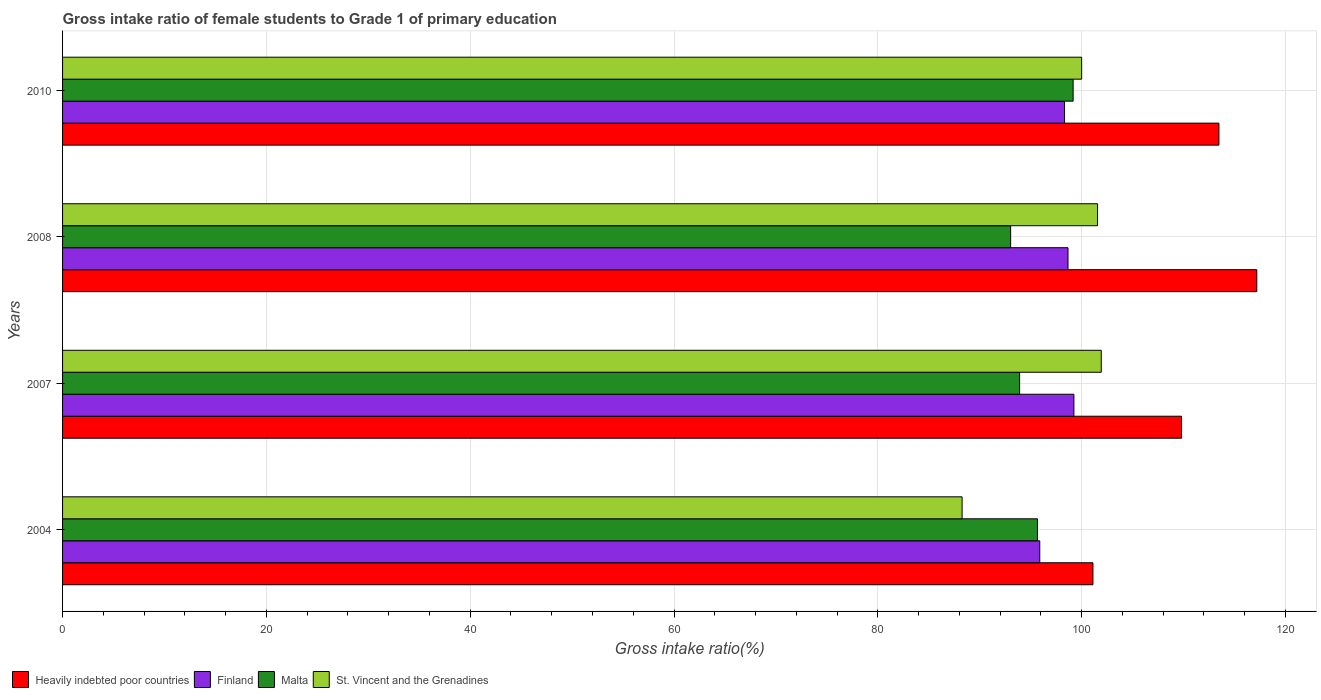How many groups of bars are there?
Make the answer very short. 4. How many bars are there on the 3rd tick from the top?
Offer a terse response. 4. How many bars are there on the 3rd tick from the bottom?
Provide a succinct answer. 4. What is the label of the 3rd group of bars from the top?
Give a very brief answer. 2007. In how many cases, is the number of bars for a given year not equal to the number of legend labels?
Provide a short and direct response. 0. What is the gross intake ratio in Malta in 2007?
Your response must be concise. 93.91. Across all years, what is the maximum gross intake ratio in Finland?
Give a very brief answer. 99.24. Across all years, what is the minimum gross intake ratio in Heavily indebted poor countries?
Your response must be concise. 101.11. What is the total gross intake ratio in St. Vincent and the Grenadines in the graph?
Your answer should be very brief. 391.75. What is the difference between the gross intake ratio in Finland in 2004 and that in 2007?
Give a very brief answer. -3.35. What is the difference between the gross intake ratio in Finland in 2010 and the gross intake ratio in Heavily indebted poor countries in 2008?
Provide a succinct answer. -18.86. What is the average gross intake ratio in St. Vincent and the Grenadines per year?
Your answer should be very brief. 97.94. In the year 2004, what is the difference between the gross intake ratio in St. Vincent and the Grenadines and gross intake ratio in Finland?
Offer a terse response. -7.62. In how many years, is the gross intake ratio in Finland greater than 32 %?
Give a very brief answer. 4. What is the ratio of the gross intake ratio in Malta in 2007 to that in 2010?
Your response must be concise. 0.95. Is the gross intake ratio in Finland in 2007 less than that in 2008?
Give a very brief answer. No. Is the difference between the gross intake ratio in St. Vincent and the Grenadines in 2008 and 2010 greater than the difference between the gross intake ratio in Finland in 2008 and 2010?
Your answer should be very brief. Yes. What is the difference between the highest and the second highest gross intake ratio in Heavily indebted poor countries?
Offer a terse response. 3.71. What is the difference between the highest and the lowest gross intake ratio in Finland?
Offer a terse response. 3.35. What does the 3rd bar from the bottom in 2007 represents?
Your response must be concise. Malta. How many years are there in the graph?
Ensure brevity in your answer.  4. Are the values on the major ticks of X-axis written in scientific E-notation?
Provide a succinct answer. No. Does the graph contain grids?
Give a very brief answer. Yes. Where does the legend appear in the graph?
Your answer should be compact. Bottom left. What is the title of the graph?
Your response must be concise. Gross intake ratio of female students to Grade 1 of primary education. What is the label or title of the X-axis?
Provide a short and direct response. Gross intake ratio(%). What is the Gross intake ratio(%) of Heavily indebted poor countries in 2004?
Your response must be concise. 101.11. What is the Gross intake ratio(%) of Finland in 2004?
Ensure brevity in your answer.  95.89. What is the Gross intake ratio(%) in Malta in 2004?
Ensure brevity in your answer.  95.67. What is the Gross intake ratio(%) in St. Vincent and the Grenadines in 2004?
Offer a very short reply. 88.27. What is the Gross intake ratio(%) in Heavily indebted poor countries in 2007?
Offer a very short reply. 109.8. What is the Gross intake ratio(%) of Finland in 2007?
Ensure brevity in your answer.  99.24. What is the Gross intake ratio(%) in Malta in 2007?
Your response must be concise. 93.91. What is the Gross intake ratio(%) in St. Vincent and the Grenadines in 2007?
Provide a succinct answer. 101.93. What is the Gross intake ratio(%) of Heavily indebted poor countries in 2008?
Make the answer very short. 117.18. What is the Gross intake ratio(%) of Finland in 2008?
Your answer should be compact. 98.66. What is the Gross intake ratio(%) in Malta in 2008?
Give a very brief answer. 93.03. What is the Gross intake ratio(%) in St. Vincent and the Grenadines in 2008?
Give a very brief answer. 101.56. What is the Gross intake ratio(%) of Heavily indebted poor countries in 2010?
Keep it short and to the point. 113.47. What is the Gross intake ratio(%) in Finland in 2010?
Offer a very short reply. 98.32. What is the Gross intake ratio(%) of Malta in 2010?
Make the answer very short. 99.16. What is the Gross intake ratio(%) of St. Vincent and the Grenadines in 2010?
Make the answer very short. 100. Across all years, what is the maximum Gross intake ratio(%) of Heavily indebted poor countries?
Ensure brevity in your answer.  117.18. Across all years, what is the maximum Gross intake ratio(%) of Finland?
Your answer should be very brief. 99.24. Across all years, what is the maximum Gross intake ratio(%) of Malta?
Your response must be concise. 99.16. Across all years, what is the maximum Gross intake ratio(%) of St. Vincent and the Grenadines?
Provide a short and direct response. 101.93. Across all years, what is the minimum Gross intake ratio(%) in Heavily indebted poor countries?
Your answer should be compact. 101.11. Across all years, what is the minimum Gross intake ratio(%) of Finland?
Offer a very short reply. 95.89. Across all years, what is the minimum Gross intake ratio(%) in Malta?
Give a very brief answer. 93.03. Across all years, what is the minimum Gross intake ratio(%) of St. Vincent and the Grenadines?
Offer a terse response. 88.27. What is the total Gross intake ratio(%) in Heavily indebted poor countries in the graph?
Your response must be concise. 441.56. What is the total Gross intake ratio(%) of Finland in the graph?
Keep it short and to the point. 392.11. What is the total Gross intake ratio(%) in Malta in the graph?
Provide a succinct answer. 381.77. What is the total Gross intake ratio(%) in St. Vincent and the Grenadines in the graph?
Provide a succinct answer. 391.75. What is the difference between the Gross intake ratio(%) in Heavily indebted poor countries in 2004 and that in 2007?
Provide a short and direct response. -8.69. What is the difference between the Gross intake ratio(%) in Finland in 2004 and that in 2007?
Your answer should be very brief. -3.35. What is the difference between the Gross intake ratio(%) in Malta in 2004 and that in 2007?
Offer a terse response. 1.75. What is the difference between the Gross intake ratio(%) of St. Vincent and the Grenadines in 2004 and that in 2007?
Offer a terse response. -13.66. What is the difference between the Gross intake ratio(%) in Heavily indebted poor countries in 2004 and that in 2008?
Make the answer very short. -16.08. What is the difference between the Gross intake ratio(%) in Finland in 2004 and that in 2008?
Give a very brief answer. -2.77. What is the difference between the Gross intake ratio(%) of Malta in 2004 and that in 2008?
Provide a succinct answer. 2.63. What is the difference between the Gross intake ratio(%) in St. Vincent and the Grenadines in 2004 and that in 2008?
Provide a short and direct response. -13.29. What is the difference between the Gross intake ratio(%) in Heavily indebted poor countries in 2004 and that in 2010?
Offer a very short reply. -12.36. What is the difference between the Gross intake ratio(%) of Finland in 2004 and that in 2010?
Make the answer very short. -2.43. What is the difference between the Gross intake ratio(%) of Malta in 2004 and that in 2010?
Give a very brief answer. -3.5. What is the difference between the Gross intake ratio(%) of St. Vincent and the Grenadines in 2004 and that in 2010?
Offer a very short reply. -11.73. What is the difference between the Gross intake ratio(%) in Heavily indebted poor countries in 2007 and that in 2008?
Provide a succinct answer. -7.38. What is the difference between the Gross intake ratio(%) in Finland in 2007 and that in 2008?
Make the answer very short. 0.58. What is the difference between the Gross intake ratio(%) in Malta in 2007 and that in 2008?
Make the answer very short. 0.88. What is the difference between the Gross intake ratio(%) in St. Vincent and the Grenadines in 2007 and that in 2008?
Provide a succinct answer. 0.36. What is the difference between the Gross intake ratio(%) of Heavily indebted poor countries in 2007 and that in 2010?
Provide a succinct answer. -3.67. What is the difference between the Gross intake ratio(%) of Finland in 2007 and that in 2010?
Offer a terse response. 0.92. What is the difference between the Gross intake ratio(%) of Malta in 2007 and that in 2010?
Provide a succinct answer. -5.25. What is the difference between the Gross intake ratio(%) of St. Vincent and the Grenadines in 2007 and that in 2010?
Ensure brevity in your answer.  1.93. What is the difference between the Gross intake ratio(%) in Heavily indebted poor countries in 2008 and that in 2010?
Keep it short and to the point. 3.71. What is the difference between the Gross intake ratio(%) of Finland in 2008 and that in 2010?
Your response must be concise. 0.34. What is the difference between the Gross intake ratio(%) in Malta in 2008 and that in 2010?
Offer a terse response. -6.13. What is the difference between the Gross intake ratio(%) in St. Vincent and the Grenadines in 2008 and that in 2010?
Give a very brief answer. 1.56. What is the difference between the Gross intake ratio(%) of Heavily indebted poor countries in 2004 and the Gross intake ratio(%) of Finland in 2007?
Provide a short and direct response. 1.87. What is the difference between the Gross intake ratio(%) of Heavily indebted poor countries in 2004 and the Gross intake ratio(%) of Malta in 2007?
Provide a short and direct response. 7.2. What is the difference between the Gross intake ratio(%) of Heavily indebted poor countries in 2004 and the Gross intake ratio(%) of St. Vincent and the Grenadines in 2007?
Make the answer very short. -0.82. What is the difference between the Gross intake ratio(%) of Finland in 2004 and the Gross intake ratio(%) of Malta in 2007?
Your response must be concise. 1.98. What is the difference between the Gross intake ratio(%) of Finland in 2004 and the Gross intake ratio(%) of St. Vincent and the Grenadines in 2007?
Provide a short and direct response. -6.03. What is the difference between the Gross intake ratio(%) of Malta in 2004 and the Gross intake ratio(%) of St. Vincent and the Grenadines in 2007?
Keep it short and to the point. -6.26. What is the difference between the Gross intake ratio(%) in Heavily indebted poor countries in 2004 and the Gross intake ratio(%) in Finland in 2008?
Offer a very short reply. 2.45. What is the difference between the Gross intake ratio(%) of Heavily indebted poor countries in 2004 and the Gross intake ratio(%) of Malta in 2008?
Your response must be concise. 8.07. What is the difference between the Gross intake ratio(%) of Heavily indebted poor countries in 2004 and the Gross intake ratio(%) of St. Vincent and the Grenadines in 2008?
Provide a short and direct response. -0.45. What is the difference between the Gross intake ratio(%) of Finland in 2004 and the Gross intake ratio(%) of Malta in 2008?
Ensure brevity in your answer.  2.86. What is the difference between the Gross intake ratio(%) of Finland in 2004 and the Gross intake ratio(%) of St. Vincent and the Grenadines in 2008?
Offer a very short reply. -5.67. What is the difference between the Gross intake ratio(%) of Malta in 2004 and the Gross intake ratio(%) of St. Vincent and the Grenadines in 2008?
Ensure brevity in your answer.  -5.9. What is the difference between the Gross intake ratio(%) in Heavily indebted poor countries in 2004 and the Gross intake ratio(%) in Finland in 2010?
Provide a succinct answer. 2.79. What is the difference between the Gross intake ratio(%) of Heavily indebted poor countries in 2004 and the Gross intake ratio(%) of Malta in 2010?
Offer a very short reply. 1.94. What is the difference between the Gross intake ratio(%) in Heavily indebted poor countries in 2004 and the Gross intake ratio(%) in St. Vincent and the Grenadines in 2010?
Keep it short and to the point. 1.11. What is the difference between the Gross intake ratio(%) in Finland in 2004 and the Gross intake ratio(%) in Malta in 2010?
Provide a short and direct response. -3.27. What is the difference between the Gross intake ratio(%) in Finland in 2004 and the Gross intake ratio(%) in St. Vincent and the Grenadines in 2010?
Your answer should be compact. -4.11. What is the difference between the Gross intake ratio(%) of Malta in 2004 and the Gross intake ratio(%) of St. Vincent and the Grenadines in 2010?
Your response must be concise. -4.33. What is the difference between the Gross intake ratio(%) of Heavily indebted poor countries in 2007 and the Gross intake ratio(%) of Finland in 2008?
Ensure brevity in your answer.  11.14. What is the difference between the Gross intake ratio(%) in Heavily indebted poor countries in 2007 and the Gross intake ratio(%) in Malta in 2008?
Your response must be concise. 16.77. What is the difference between the Gross intake ratio(%) of Heavily indebted poor countries in 2007 and the Gross intake ratio(%) of St. Vincent and the Grenadines in 2008?
Your answer should be compact. 8.24. What is the difference between the Gross intake ratio(%) of Finland in 2007 and the Gross intake ratio(%) of Malta in 2008?
Your answer should be compact. 6.21. What is the difference between the Gross intake ratio(%) of Finland in 2007 and the Gross intake ratio(%) of St. Vincent and the Grenadines in 2008?
Give a very brief answer. -2.32. What is the difference between the Gross intake ratio(%) of Malta in 2007 and the Gross intake ratio(%) of St. Vincent and the Grenadines in 2008?
Your response must be concise. -7.65. What is the difference between the Gross intake ratio(%) in Heavily indebted poor countries in 2007 and the Gross intake ratio(%) in Finland in 2010?
Make the answer very short. 11.48. What is the difference between the Gross intake ratio(%) in Heavily indebted poor countries in 2007 and the Gross intake ratio(%) in Malta in 2010?
Offer a terse response. 10.64. What is the difference between the Gross intake ratio(%) of Heavily indebted poor countries in 2007 and the Gross intake ratio(%) of St. Vincent and the Grenadines in 2010?
Your response must be concise. 9.8. What is the difference between the Gross intake ratio(%) in Finland in 2007 and the Gross intake ratio(%) in Malta in 2010?
Your answer should be compact. 0.08. What is the difference between the Gross intake ratio(%) in Finland in 2007 and the Gross intake ratio(%) in St. Vincent and the Grenadines in 2010?
Keep it short and to the point. -0.76. What is the difference between the Gross intake ratio(%) in Malta in 2007 and the Gross intake ratio(%) in St. Vincent and the Grenadines in 2010?
Offer a very short reply. -6.09. What is the difference between the Gross intake ratio(%) of Heavily indebted poor countries in 2008 and the Gross intake ratio(%) of Finland in 2010?
Provide a succinct answer. 18.86. What is the difference between the Gross intake ratio(%) in Heavily indebted poor countries in 2008 and the Gross intake ratio(%) in Malta in 2010?
Ensure brevity in your answer.  18.02. What is the difference between the Gross intake ratio(%) of Heavily indebted poor countries in 2008 and the Gross intake ratio(%) of St. Vincent and the Grenadines in 2010?
Provide a short and direct response. 17.18. What is the difference between the Gross intake ratio(%) of Finland in 2008 and the Gross intake ratio(%) of Malta in 2010?
Offer a terse response. -0.5. What is the difference between the Gross intake ratio(%) of Finland in 2008 and the Gross intake ratio(%) of St. Vincent and the Grenadines in 2010?
Your answer should be compact. -1.34. What is the difference between the Gross intake ratio(%) in Malta in 2008 and the Gross intake ratio(%) in St. Vincent and the Grenadines in 2010?
Make the answer very short. -6.97. What is the average Gross intake ratio(%) in Heavily indebted poor countries per year?
Offer a very short reply. 110.39. What is the average Gross intake ratio(%) in Finland per year?
Your answer should be very brief. 98.03. What is the average Gross intake ratio(%) in Malta per year?
Your response must be concise. 95.44. What is the average Gross intake ratio(%) of St. Vincent and the Grenadines per year?
Provide a succinct answer. 97.94. In the year 2004, what is the difference between the Gross intake ratio(%) in Heavily indebted poor countries and Gross intake ratio(%) in Finland?
Keep it short and to the point. 5.22. In the year 2004, what is the difference between the Gross intake ratio(%) in Heavily indebted poor countries and Gross intake ratio(%) in Malta?
Your response must be concise. 5.44. In the year 2004, what is the difference between the Gross intake ratio(%) of Heavily indebted poor countries and Gross intake ratio(%) of St. Vincent and the Grenadines?
Keep it short and to the point. 12.84. In the year 2004, what is the difference between the Gross intake ratio(%) in Finland and Gross intake ratio(%) in Malta?
Offer a very short reply. 0.23. In the year 2004, what is the difference between the Gross intake ratio(%) in Finland and Gross intake ratio(%) in St. Vincent and the Grenadines?
Your answer should be compact. 7.62. In the year 2004, what is the difference between the Gross intake ratio(%) in Malta and Gross intake ratio(%) in St. Vincent and the Grenadines?
Offer a very short reply. 7.4. In the year 2007, what is the difference between the Gross intake ratio(%) of Heavily indebted poor countries and Gross intake ratio(%) of Finland?
Keep it short and to the point. 10.56. In the year 2007, what is the difference between the Gross intake ratio(%) in Heavily indebted poor countries and Gross intake ratio(%) in Malta?
Offer a very short reply. 15.89. In the year 2007, what is the difference between the Gross intake ratio(%) in Heavily indebted poor countries and Gross intake ratio(%) in St. Vincent and the Grenadines?
Your answer should be compact. 7.88. In the year 2007, what is the difference between the Gross intake ratio(%) in Finland and Gross intake ratio(%) in Malta?
Make the answer very short. 5.33. In the year 2007, what is the difference between the Gross intake ratio(%) of Finland and Gross intake ratio(%) of St. Vincent and the Grenadines?
Provide a short and direct response. -2.68. In the year 2007, what is the difference between the Gross intake ratio(%) of Malta and Gross intake ratio(%) of St. Vincent and the Grenadines?
Make the answer very short. -8.01. In the year 2008, what is the difference between the Gross intake ratio(%) in Heavily indebted poor countries and Gross intake ratio(%) in Finland?
Provide a succinct answer. 18.52. In the year 2008, what is the difference between the Gross intake ratio(%) in Heavily indebted poor countries and Gross intake ratio(%) in Malta?
Ensure brevity in your answer.  24.15. In the year 2008, what is the difference between the Gross intake ratio(%) of Heavily indebted poor countries and Gross intake ratio(%) of St. Vincent and the Grenadines?
Provide a succinct answer. 15.62. In the year 2008, what is the difference between the Gross intake ratio(%) of Finland and Gross intake ratio(%) of Malta?
Your answer should be compact. 5.63. In the year 2008, what is the difference between the Gross intake ratio(%) in Finland and Gross intake ratio(%) in St. Vincent and the Grenadines?
Your answer should be compact. -2.9. In the year 2008, what is the difference between the Gross intake ratio(%) of Malta and Gross intake ratio(%) of St. Vincent and the Grenadines?
Offer a very short reply. -8.53. In the year 2010, what is the difference between the Gross intake ratio(%) of Heavily indebted poor countries and Gross intake ratio(%) of Finland?
Your answer should be very brief. 15.15. In the year 2010, what is the difference between the Gross intake ratio(%) in Heavily indebted poor countries and Gross intake ratio(%) in Malta?
Keep it short and to the point. 14.31. In the year 2010, what is the difference between the Gross intake ratio(%) of Heavily indebted poor countries and Gross intake ratio(%) of St. Vincent and the Grenadines?
Your answer should be compact. 13.47. In the year 2010, what is the difference between the Gross intake ratio(%) of Finland and Gross intake ratio(%) of Malta?
Provide a short and direct response. -0.84. In the year 2010, what is the difference between the Gross intake ratio(%) in Finland and Gross intake ratio(%) in St. Vincent and the Grenadines?
Ensure brevity in your answer.  -1.68. In the year 2010, what is the difference between the Gross intake ratio(%) in Malta and Gross intake ratio(%) in St. Vincent and the Grenadines?
Offer a very short reply. -0.84. What is the ratio of the Gross intake ratio(%) in Heavily indebted poor countries in 2004 to that in 2007?
Keep it short and to the point. 0.92. What is the ratio of the Gross intake ratio(%) of Finland in 2004 to that in 2007?
Your answer should be compact. 0.97. What is the ratio of the Gross intake ratio(%) of Malta in 2004 to that in 2007?
Keep it short and to the point. 1.02. What is the ratio of the Gross intake ratio(%) of St. Vincent and the Grenadines in 2004 to that in 2007?
Your answer should be compact. 0.87. What is the ratio of the Gross intake ratio(%) of Heavily indebted poor countries in 2004 to that in 2008?
Provide a short and direct response. 0.86. What is the ratio of the Gross intake ratio(%) in Finland in 2004 to that in 2008?
Provide a succinct answer. 0.97. What is the ratio of the Gross intake ratio(%) of Malta in 2004 to that in 2008?
Your answer should be very brief. 1.03. What is the ratio of the Gross intake ratio(%) of St. Vincent and the Grenadines in 2004 to that in 2008?
Make the answer very short. 0.87. What is the ratio of the Gross intake ratio(%) in Heavily indebted poor countries in 2004 to that in 2010?
Your response must be concise. 0.89. What is the ratio of the Gross intake ratio(%) of Finland in 2004 to that in 2010?
Your answer should be very brief. 0.98. What is the ratio of the Gross intake ratio(%) in Malta in 2004 to that in 2010?
Keep it short and to the point. 0.96. What is the ratio of the Gross intake ratio(%) of St. Vincent and the Grenadines in 2004 to that in 2010?
Your answer should be compact. 0.88. What is the ratio of the Gross intake ratio(%) of Heavily indebted poor countries in 2007 to that in 2008?
Make the answer very short. 0.94. What is the ratio of the Gross intake ratio(%) in Finland in 2007 to that in 2008?
Your response must be concise. 1.01. What is the ratio of the Gross intake ratio(%) in Malta in 2007 to that in 2008?
Ensure brevity in your answer.  1.01. What is the ratio of the Gross intake ratio(%) of St. Vincent and the Grenadines in 2007 to that in 2008?
Ensure brevity in your answer.  1. What is the ratio of the Gross intake ratio(%) in Heavily indebted poor countries in 2007 to that in 2010?
Offer a terse response. 0.97. What is the ratio of the Gross intake ratio(%) in Finland in 2007 to that in 2010?
Provide a succinct answer. 1.01. What is the ratio of the Gross intake ratio(%) of Malta in 2007 to that in 2010?
Your answer should be very brief. 0.95. What is the ratio of the Gross intake ratio(%) in St. Vincent and the Grenadines in 2007 to that in 2010?
Give a very brief answer. 1.02. What is the ratio of the Gross intake ratio(%) of Heavily indebted poor countries in 2008 to that in 2010?
Your response must be concise. 1.03. What is the ratio of the Gross intake ratio(%) in Malta in 2008 to that in 2010?
Provide a succinct answer. 0.94. What is the ratio of the Gross intake ratio(%) in St. Vincent and the Grenadines in 2008 to that in 2010?
Give a very brief answer. 1.02. What is the difference between the highest and the second highest Gross intake ratio(%) of Heavily indebted poor countries?
Your answer should be compact. 3.71. What is the difference between the highest and the second highest Gross intake ratio(%) of Finland?
Keep it short and to the point. 0.58. What is the difference between the highest and the second highest Gross intake ratio(%) in Malta?
Ensure brevity in your answer.  3.5. What is the difference between the highest and the second highest Gross intake ratio(%) of St. Vincent and the Grenadines?
Offer a very short reply. 0.36. What is the difference between the highest and the lowest Gross intake ratio(%) of Heavily indebted poor countries?
Offer a terse response. 16.08. What is the difference between the highest and the lowest Gross intake ratio(%) in Finland?
Offer a very short reply. 3.35. What is the difference between the highest and the lowest Gross intake ratio(%) of Malta?
Your answer should be very brief. 6.13. What is the difference between the highest and the lowest Gross intake ratio(%) of St. Vincent and the Grenadines?
Ensure brevity in your answer.  13.66. 